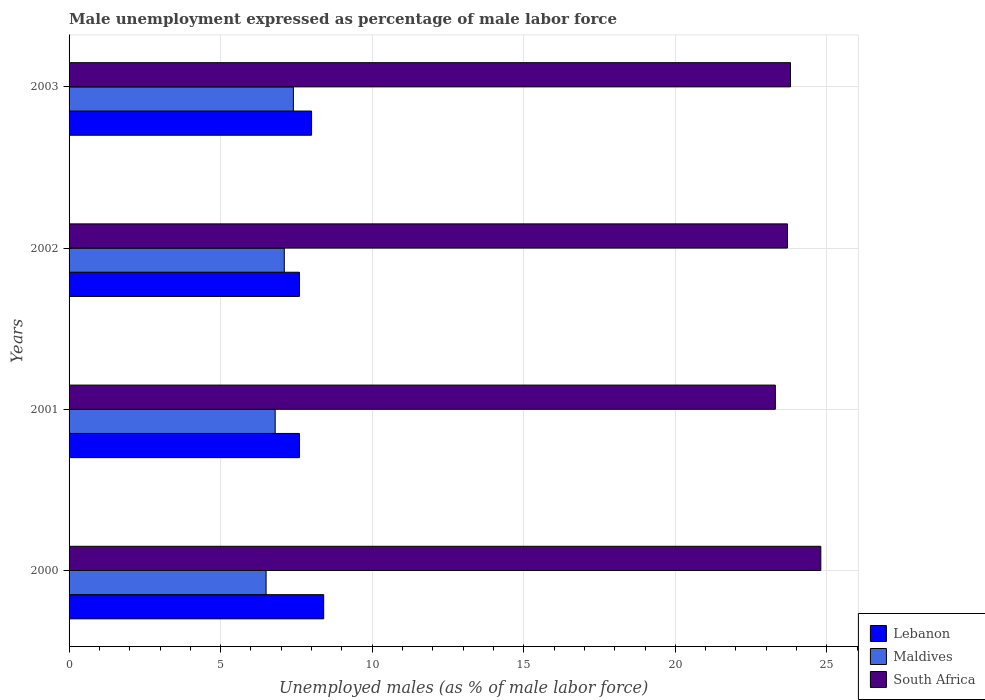How many different coloured bars are there?
Your response must be concise. 3. How many groups of bars are there?
Your answer should be very brief. 4. How many bars are there on the 4th tick from the top?
Offer a very short reply. 3. What is the label of the 3rd group of bars from the top?
Provide a short and direct response. 2001. What is the unemployment in males in in Lebanon in 2002?
Ensure brevity in your answer.  7.6. Across all years, what is the maximum unemployment in males in in South Africa?
Provide a short and direct response. 24.8. Across all years, what is the minimum unemployment in males in in Lebanon?
Your response must be concise. 7.6. In which year was the unemployment in males in in Maldives maximum?
Your answer should be compact. 2003. In which year was the unemployment in males in in Maldives minimum?
Offer a very short reply. 2000. What is the total unemployment in males in in Maldives in the graph?
Offer a very short reply. 27.8. What is the difference between the unemployment in males in in Lebanon in 2000 and that in 2001?
Your answer should be compact. 0.8. What is the difference between the unemployment in males in in Lebanon in 2003 and the unemployment in males in in South Africa in 2002?
Provide a short and direct response. -15.7. What is the average unemployment in males in in Lebanon per year?
Your answer should be very brief. 7.9. In the year 2000, what is the difference between the unemployment in males in in Maldives and unemployment in males in in Lebanon?
Your response must be concise. -1.9. In how many years, is the unemployment in males in in Lebanon greater than 8 %?
Offer a terse response. 1. What is the ratio of the unemployment in males in in South Africa in 2001 to that in 2002?
Offer a very short reply. 0.98. What is the difference between the highest and the lowest unemployment in males in in Maldives?
Keep it short and to the point. 0.9. In how many years, is the unemployment in males in in Maldives greater than the average unemployment in males in in Maldives taken over all years?
Keep it short and to the point. 2. What does the 2nd bar from the top in 2000 represents?
Offer a terse response. Maldives. What does the 2nd bar from the bottom in 2001 represents?
Your answer should be very brief. Maldives. Is it the case that in every year, the sum of the unemployment in males in in Lebanon and unemployment in males in in South Africa is greater than the unemployment in males in in Maldives?
Your answer should be compact. Yes. Are all the bars in the graph horizontal?
Your answer should be compact. Yes. How many years are there in the graph?
Your answer should be compact. 4. Are the values on the major ticks of X-axis written in scientific E-notation?
Ensure brevity in your answer.  No. Does the graph contain grids?
Provide a short and direct response. Yes. Where does the legend appear in the graph?
Your response must be concise. Bottom right. How many legend labels are there?
Provide a succinct answer. 3. What is the title of the graph?
Make the answer very short. Male unemployment expressed as percentage of male labor force. Does "Bulgaria" appear as one of the legend labels in the graph?
Make the answer very short. No. What is the label or title of the X-axis?
Offer a terse response. Unemployed males (as % of male labor force). What is the label or title of the Y-axis?
Make the answer very short. Years. What is the Unemployed males (as % of male labor force) of Lebanon in 2000?
Your response must be concise. 8.4. What is the Unemployed males (as % of male labor force) of Maldives in 2000?
Offer a terse response. 6.5. What is the Unemployed males (as % of male labor force) in South Africa in 2000?
Offer a terse response. 24.8. What is the Unemployed males (as % of male labor force) in Lebanon in 2001?
Provide a short and direct response. 7.6. What is the Unemployed males (as % of male labor force) in Maldives in 2001?
Make the answer very short. 6.8. What is the Unemployed males (as % of male labor force) of South Africa in 2001?
Offer a terse response. 23.3. What is the Unemployed males (as % of male labor force) of Lebanon in 2002?
Your answer should be compact. 7.6. What is the Unemployed males (as % of male labor force) in Maldives in 2002?
Your answer should be compact. 7.1. What is the Unemployed males (as % of male labor force) of South Africa in 2002?
Provide a succinct answer. 23.7. What is the Unemployed males (as % of male labor force) of Lebanon in 2003?
Offer a very short reply. 8. What is the Unemployed males (as % of male labor force) in Maldives in 2003?
Provide a succinct answer. 7.4. What is the Unemployed males (as % of male labor force) of South Africa in 2003?
Keep it short and to the point. 23.8. Across all years, what is the maximum Unemployed males (as % of male labor force) of Lebanon?
Provide a short and direct response. 8.4. Across all years, what is the maximum Unemployed males (as % of male labor force) of Maldives?
Offer a very short reply. 7.4. Across all years, what is the maximum Unemployed males (as % of male labor force) of South Africa?
Ensure brevity in your answer.  24.8. Across all years, what is the minimum Unemployed males (as % of male labor force) of Lebanon?
Provide a succinct answer. 7.6. Across all years, what is the minimum Unemployed males (as % of male labor force) in Maldives?
Provide a succinct answer. 6.5. Across all years, what is the minimum Unemployed males (as % of male labor force) in South Africa?
Your answer should be very brief. 23.3. What is the total Unemployed males (as % of male labor force) of Lebanon in the graph?
Provide a succinct answer. 31.6. What is the total Unemployed males (as % of male labor force) of Maldives in the graph?
Your answer should be very brief. 27.8. What is the total Unemployed males (as % of male labor force) of South Africa in the graph?
Ensure brevity in your answer.  95.6. What is the difference between the Unemployed males (as % of male labor force) in Maldives in 2000 and that in 2001?
Your answer should be very brief. -0.3. What is the difference between the Unemployed males (as % of male labor force) of South Africa in 2000 and that in 2002?
Offer a terse response. 1.1. What is the difference between the Unemployed males (as % of male labor force) of Lebanon in 2000 and that in 2003?
Your answer should be very brief. 0.4. What is the difference between the Unemployed males (as % of male labor force) of South Africa in 2000 and that in 2003?
Provide a succinct answer. 1. What is the difference between the Unemployed males (as % of male labor force) in Maldives in 2001 and that in 2002?
Give a very brief answer. -0.3. What is the difference between the Unemployed males (as % of male labor force) in Lebanon in 2001 and that in 2003?
Ensure brevity in your answer.  -0.4. What is the difference between the Unemployed males (as % of male labor force) in Maldives in 2001 and that in 2003?
Ensure brevity in your answer.  -0.6. What is the difference between the Unemployed males (as % of male labor force) of South Africa in 2002 and that in 2003?
Provide a succinct answer. -0.1. What is the difference between the Unemployed males (as % of male labor force) in Lebanon in 2000 and the Unemployed males (as % of male labor force) in South Africa in 2001?
Your answer should be very brief. -14.9. What is the difference between the Unemployed males (as % of male labor force) in Maldives in 2000 and the Unemployed males (as % of male labor force) in South Africa in 2001?
Keep it short and to the point. -16.8. What is the difference between the Unemployed males (as % of male labor force) in Lebanon in 2000 and the Unemployed males (as % of male labor force) in South Africa in 2002?
Offer a terse response. -15.3. What is the difference between the Unemployed males (as % of male labor force) of Maldives in 2000 and the Unemployed males (as % of male labor force) of South Africa in 2002?
Offer a very short reply. -17.2. What is the difference between the Unemployed males (as % of male labor force) of Lebanon in 2000 and the Unemployed males (as % of male labor force) of Maldives in 2003?
Offer a very short reply. 1. What is the difference between the Unemployed males (as % of male labor force) of Lebanon in 2000 and the Unemployed males (as % of male labor force) of South Africa in 2003?
Offer a very short reply. -15.4. What is the difference between the Unemployed males (as % of male labor force) in Maldives in 2000 and the Unemployed males (as % of male labor force) in South Africa in 2003?
Your answer should be very brief. -17.3. What is the difference between the Unemployed males (as % of male labor force) of Lebanon in 2001 and the Unemployed males (as % of male labor force) of South Africa in 2002?
Offer a very short reply. -16.1. What is the difference between the Unemployed males (as % of male labor force) in Maldives in 2001 and the Unemployed males (as % of male labor force) in South Africa in 2002?
Keep it short and to the point. -16.9. What is the difference between the Unemployed males (as % of male labor force) in Lebanon in 2001 and the Unemployed males (as % of male labor force) in Maldives in 2003?
Your response must be concise. 0.2. What is the difference between the Unemployed males (as % of male labor force) in Lebanon in 2001 and the Unemployed males (as % of male labor force) in South Africa in 2003?
Your answer should be compact. -16.2. What is the difference between the Unemployed males (as % of male labor force) in Lebanon in 2002 and the Unemployed males (as % of male labor force) in Maldives in 2003?
Keep it short and to the point. 0.2. What is the difference between the Unemployed males (as % of male labor force) of Lebanon in 2002 and the Unemployed males (as % of male labor force) of South Africa in 2003?
Your answer should be compact. -16.2. What is the difference between the Unemployed males (as % of male labor force) of Maldives in 2002 and the Unemployed males (as % of male labor force) of South Africa in 2003?
Your answer should be very brief. -16.7. What is the average Unemployed males (as % of male labor force) in Maldives per year?
Give a very brief answer. 6.95. What is the average Unemployed males (as % of male labor force) in South Africa per year?
Provide a succinct answer. 23.9. In the year 2000, what is the difference between the Unemployed males (as % of male labor force) of Lebanon and Unemployed males (as % of male labor force) of South Africa?
Provide a short and direct response. -16.4. In the year 2000, what is the difference between the Unemployed males (as % of male labor force) in Maldives and Unemployed males (as % of male labor force) in South Africa?
Ensure brevity in your answer.  -18.3. In the year 2001, what is the difference between the Unemployed males (as % of male labor force) in Lebanon and Unemployed males (as % of male labor force) in South Africa?
Make the answer very short. -15.7. In the year 2001, what is the difference between the Unemployed males (as % of male labor force) in Maldives and Unemployed males (as % of male labor force) in South Africa?
Your response must be concise. -16.5. In the year 2002, what is the difference between the Unemployed males (as % of male labor force) in Lebanon and Unemployed males (as % of male labor force) in South Africa?
Offer a very short reply. -16.1. In the year 2002, what is the difference between the Unemployed males (as % of male labor force) in Maldives and Unemployed males (as % of male labor force) in South Africa?
Keep it short and to the point. -16.6. In the year 2003, what is the difference between the Unemployed males (as % of male labor force) in Lebanon and Unemployed males (as % of male labor force) in Maldives?
Keep it short and to the point. 0.6. In the year 2003, what is the difference between the Unemployed males (as % of male labor force) of Lebanon and Unemployed males (as % of male labor force) of South Africa?
Make the answer very short. -15.8. In the year 2003, what is the difference between the Unemployed males (as % of male labor force) of Maldives and Unemployed males (as % of male labor force) of South Africa?
Offer a terse response. -16.4. What is the ratio of the Unemployed males (as % of male labor force) in Lebanon in 2000 to that in 2001?
Offer a terse response. 1.11. What is the ratio of the Unemployed males (as % of male labor force) of Maldives in 2000 to that in 2001?
Your response must be concise. 0.96. What is the ratio of the Unemployed males (as % of male labor force) in South Africa in 2000 to that in 2001?
Offer a terse response. 1.06. What is the ratio of the Unemployed males (as % of male labor force) of Lebanon in 2000 to that in 2002?
Provide a succinct answer. 1.11. What is the ratio of the Unemployed males (as % of male labor force) in Maldives in 2000 to that in 2002?
Your response must be concise. 0.92. What is the ratio of the Unemployed males (as % of male labor force) in South Africa in 2000 to that in 2002?
Offer a very short reply. 1.05. What is the ratio of the Unemployed males (as % of male labor force) of Lebanon in 2000 to that in 2003?
Your answer should be very brief. 1.05. What is the ratio of the Unemployed males (as % of male labor force) of Maldives in 2000 to that in 2003?
Offer a very short reply. 0.88. What is the ratio of the Unemployed males (as % of male labor force) in South Africa in 2000 to that in 2003?
Ensure brevity in your answer.  1.04. What is the ratio of the Unemployed males (as % of male labor force) of Maldives in 2001 to that in 2002?
Keep it short and to the point. 0.96. What is the ratio of the Unemployed males (as % of male labor force) in South Africa in 2001 to that in 2002?
Make the answer very short. 0.98. What is the ratio of the Unemployed males (as % of male labor force) of Lebanon in 2001 to that in 2003?
Make the answer very short. 0.95. What is the ratio of the Unemployed males (as % of male labor force) in Maldives in 2001 to that in 2003?
Make the answer very short. 0.92. What is the ratio of the Unemployed males (as % of male labor force) of Maldives in 2002 to that in 2003?
Keep it short and to the point. 0.96. What is the ratio of the Unemployed males (as % of male labor force) in South Africa in 2002 to that in 2003?
Offer a terse response. 1. What is the difference between the highest and the second highest Unemployed males (as % of male labor force) in Maldives?
Your response must be concise. 0.3. What is the difference between the highest and the second highest Unemployed males (as % of male labor force) in South Africa?
Keep it short and to the point. 1. What is the difference between the highest and the lowest Unemployed males (as % of male labor force) of Maldives?
Offer a terse response. 0.9. 